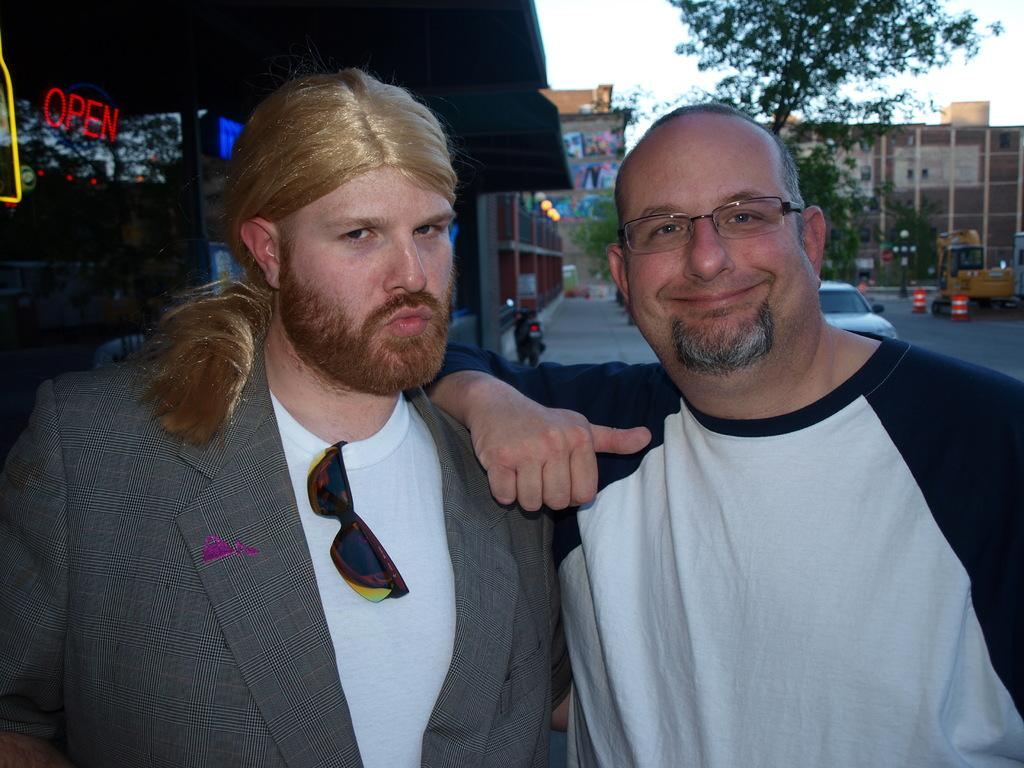How many people are in the image? There are two persons in the image. What is one person holding in the image? One person is holding spectacles. Where are the spectacles placed in the image? The spectacles are placed on a t-shirt. What can be seen in the background of the image? Buildings, vehicles, and trees are visible in the background. What type of wood can be seen on the island in the image? There is no island present in the image, and therefore no wood can be observed. What noise can be heard coming from the vehicles in the image? The image is static, so no noise can be heard from the vehicles. 